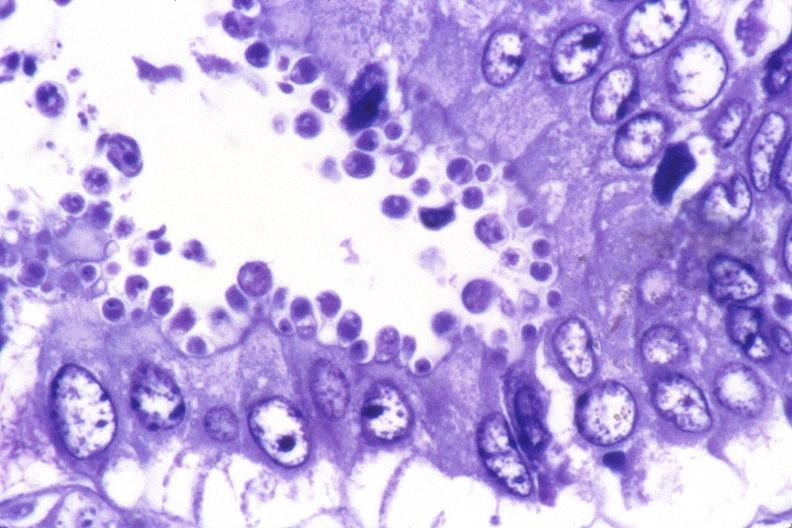where is this from?
Answer the question using a single word or phrase. Gastrointestinal system 